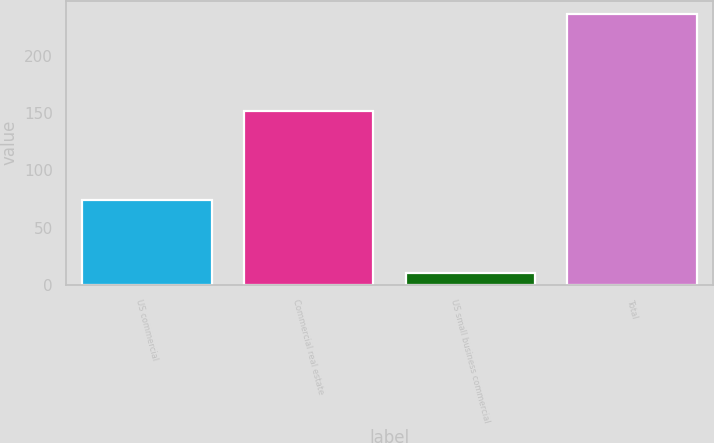<chart> <loc_0><loc_0><loc_500><loc_500><bar_chart><fcel>US commercial<fcel>Commercial real estate<fcel>US small business commercial<fcel>Total<nl><fcel>74<fcel>152<fcel>10<fcel>236<nl></chart> 